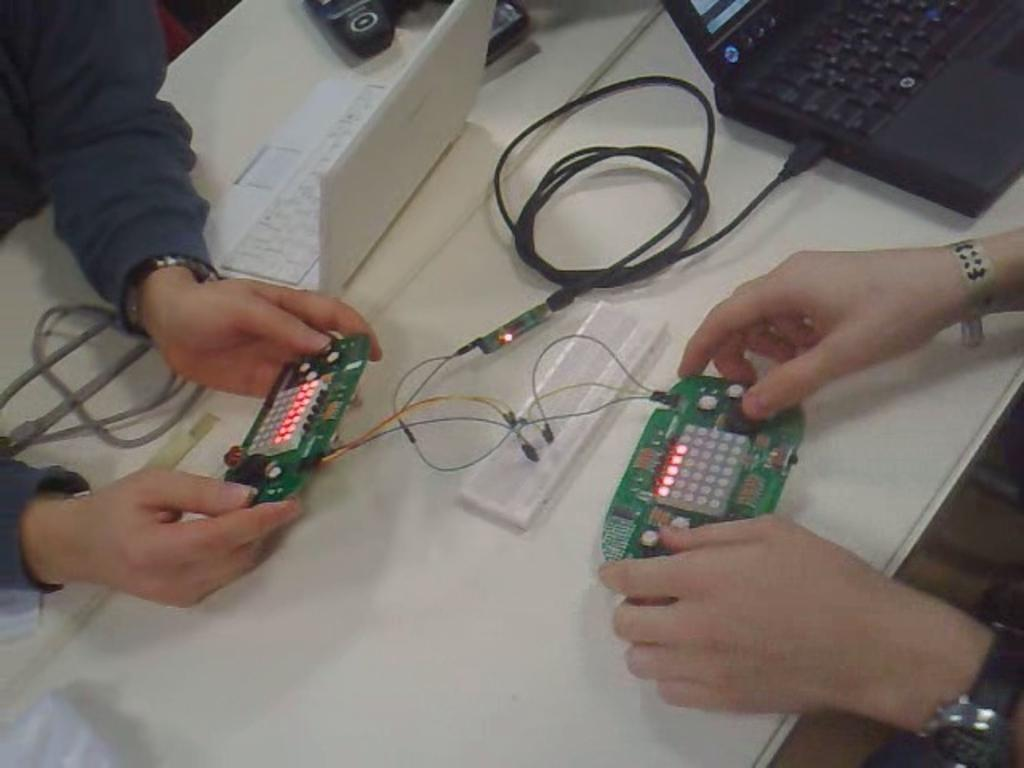What is the main piece of furniture in the image? There is a table in the image. What electronic devices are on the table? There are laptops on the table. What else can be seen on the table besides laptops? There are cables and other objects on the table. How many people are in the image? There are two people in the image. What are the people holding in their hands? The hands of the two people are holding objects. What reward can be seen on the table in the image? There is no reward present on the table in the image. What detail about the cables on the table can be observed in the image? The provided facts do not mention any specific details about the cables on the table. 